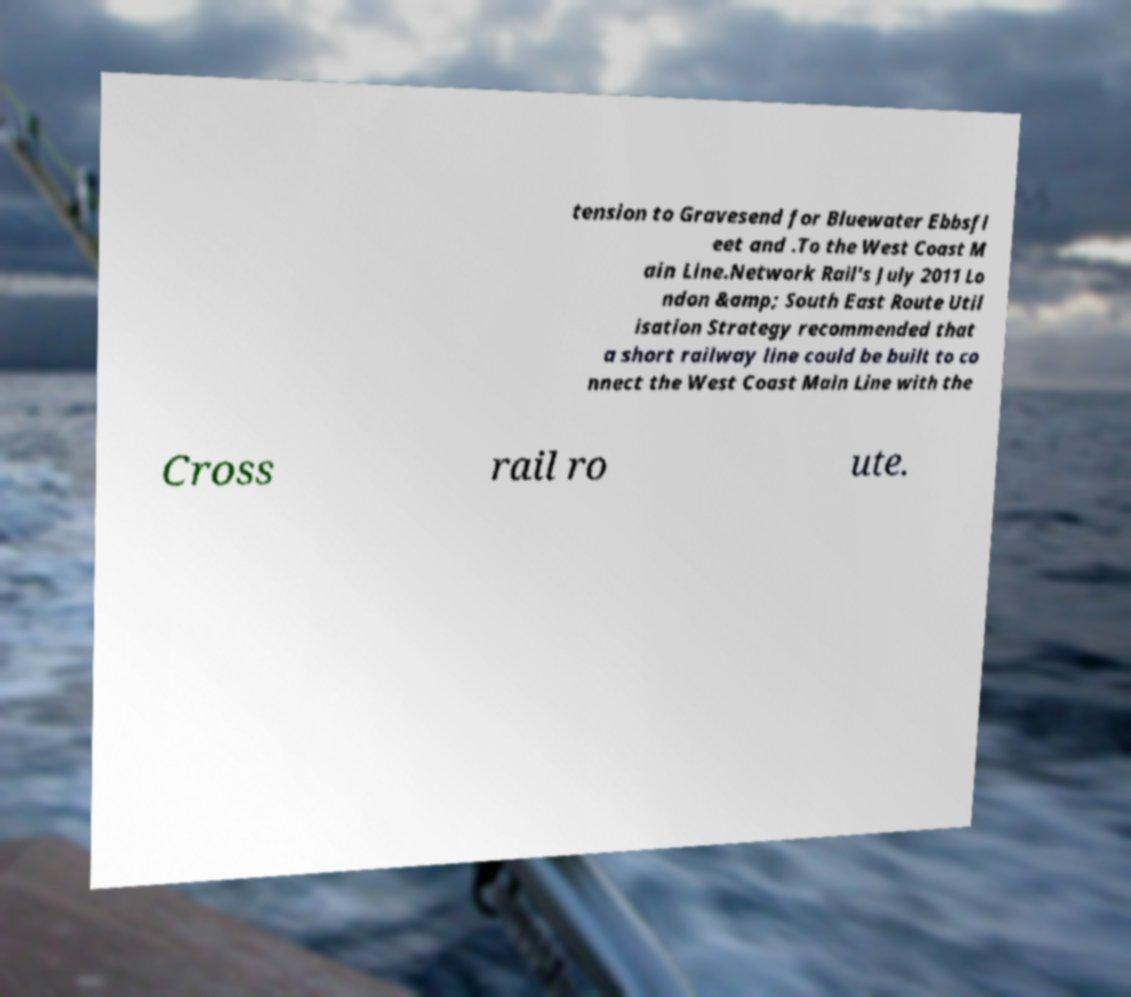There's text embedded in this image that I need extracted. Can you transcribe it verbatim? tension to Gravesend for Bluewater Ebbsfl eet and .To the West Coast M ain Line.Network Rail's July 2011 Lo ndon &amp; South East Route Util isation Strategy recommended that a short railway line could be built to co nnect the West Coast Main Line with the Cross rail ro ute. 